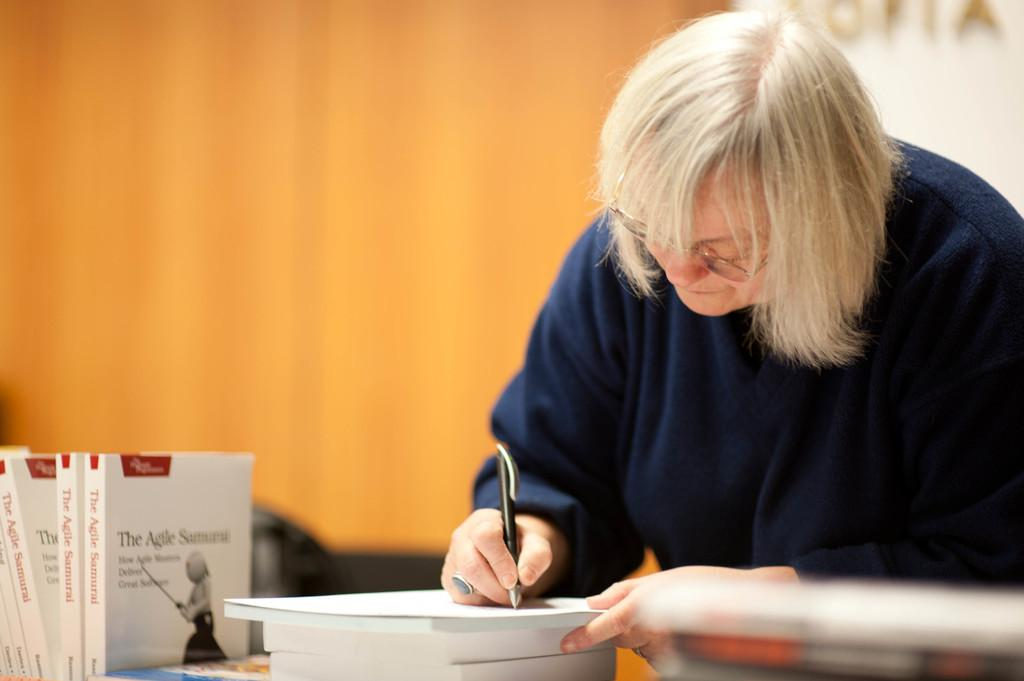<image>
Describe the image concisely. A person with grey hair is writing on a stack of books called The Agile Samurai. 